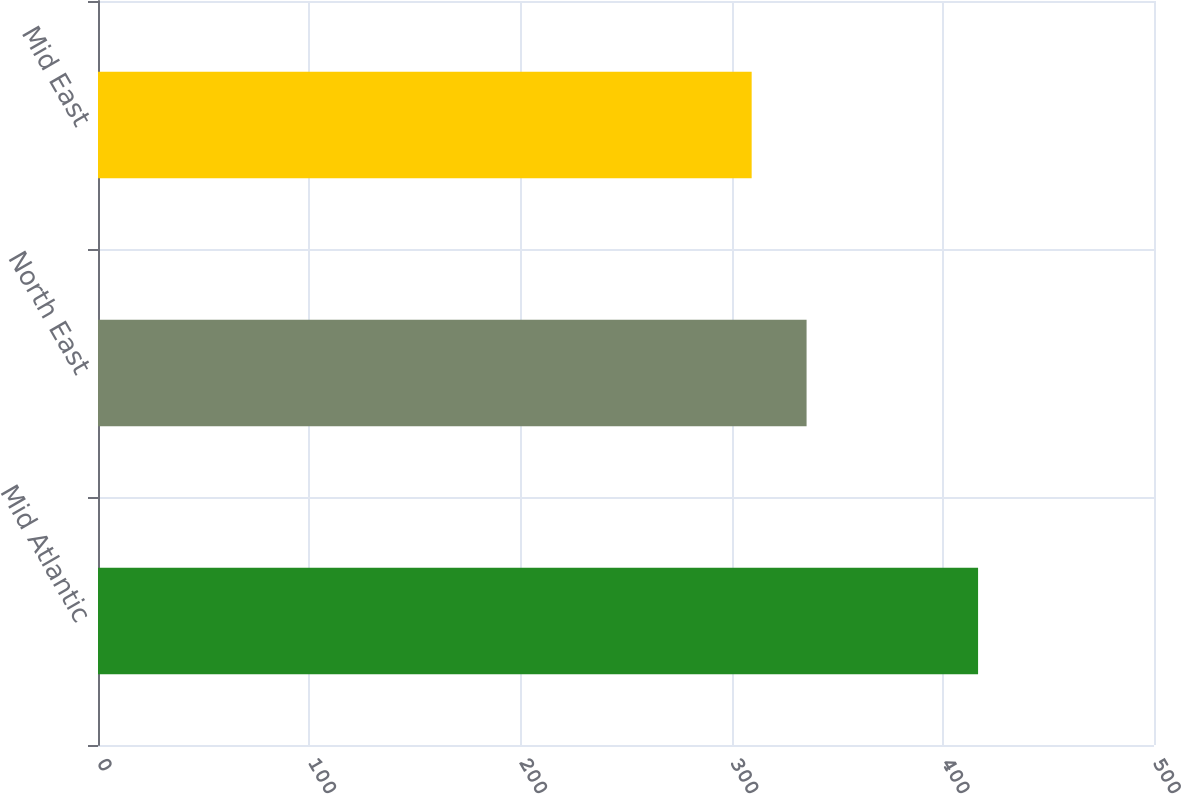Convert chart to OTSL. <chart><loc_0><loc_0><loc_500><loc_500><bar_chart><fcel>Mid Atlantic<fcel>North East<fcel>Mid East<nl><fcel>416.7<fcel>335.5<fcel>309.5<nl></chart> 